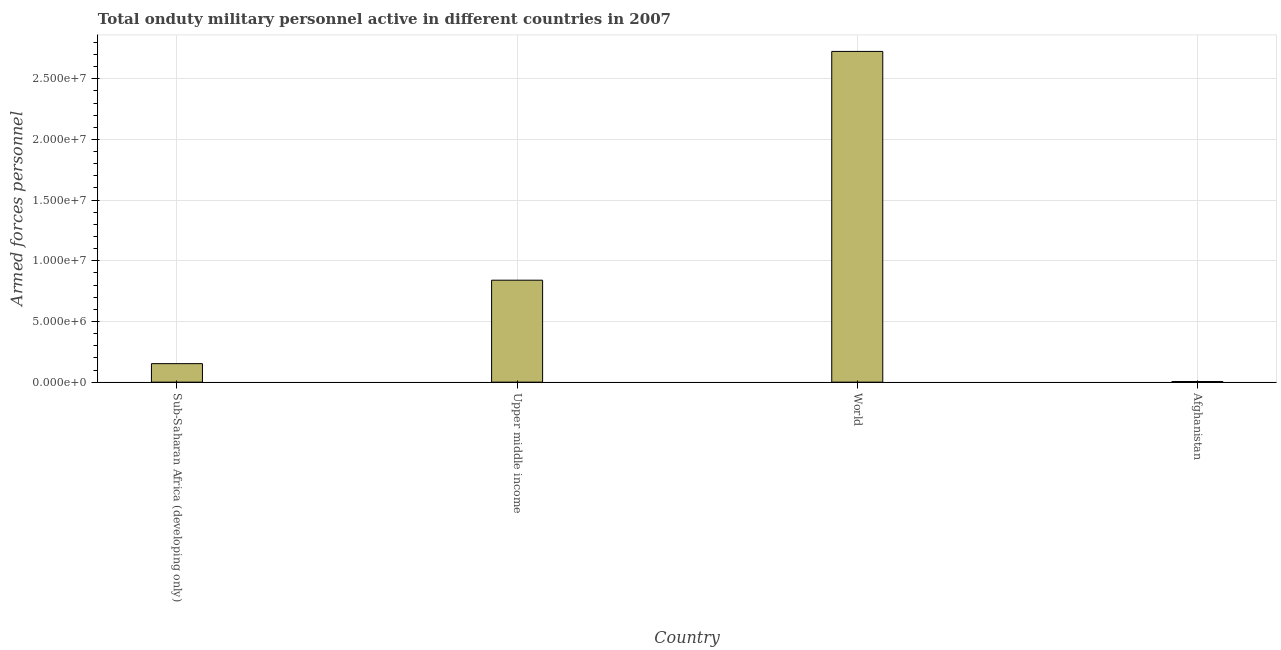Does the graph contain any zero values?
Provide a short and direct response. No. What is the title of the graph?
Your answer should be compact. Total onduty military personnel active in different countries in 2007. What is the label or title of the Y-axis?
Your response must be concise. Armed forces personnel. What is the number of armed forces personnel in Afghanistan?
Give a very brief answer. 5.10e+04. Across all countries, what is the maximum number of armed forces personnel?
Your response must be concise. 2.73e+07. Across all countries, what is the minimum number of armed forces personnel?
Your answer should be compact. 5.10e+04. In which country was the number of armed forces personnel minimum?
Ensure brevity in your answer.  Afghanistan. What is the sum of the number of armed forces personnel?
Offer a terse response. 3.72e+07. What is the difference between the number of armed forces personnel in Sub-Saharan Africa (developing only) and Upper middle income?
Keep it short and to the point. -6.88e+06. What is the average number of armed forces personnel per country?
Your response must be concise. 9.31e+06. What is the median number of armed forces personnel?
Offer a terse response. 4.96e+06. In how many countries, is the number of armed forces personnel greater than 22000000 ?
Provide a succinct answer. 1. What is the ratio of the number of armed forces personnel in Afghanistan to that in Upper middle income?
Your answer should be very brief. 0.01. Is the number of armed forces personnel in Sub-Saharan Africa (developing only) less than that in World?
Give a very brief answer. Yes. What is the difference between the highest and the second highest number of armed forces personnel?
Provide a succinct answer. 1.89e+07. What is the difference between the highest and the lowest number of armed forces personnel?
Provide a short and direct response. 2.72e+07. Are all the bars in the graph horizontal?
Offer a terse response. No. How many countries are there in the graph?
Ensure brevity in your answer.  4. What is the Armed forces personnel of Sub-Saharan Africa (developing only)?
Provide a succinct answer. 1.52e+06. What is the Armed forces personnel in Upper middle income?
Provide a short and direct response. 8.40e+06. What is the Armed forces personnel of World?
Provide a succinct answer. 2.73e+07. What is the Armed forces personnel in Afghanistan?
Provide a succinct answer. 5.10e+04. What is the difference between the Armed forces personnel in Sub-Saharan Africa (developing only) and Upper middle income?
Offer a very short reply. -6.88e+06. What is the difference between the Armed forces personnel in Sub-Saharan Africa (developing only) and World?
Your answer should be compact. -2.57e+07. What is the difference between the Armed forces personnel in Sub-Saharan Africa (developing only) and Afghanistan?
Offer a terse response. 1.47e+06. What is the difference between the Armed forces personnel in Upper middle income and World?
Ensure brevity in your answer.  -1.89e+07. What is the difference between the Armed forces personnel in Upper middle income and Afghanistan?
Make the answer very short. 8.35e+06. What is the difference between the Armed forces personnel in World and Afghanistan?
Keep it short and to the point. 2.72e+07. What is the ratio of the Armed forces personnel in Sub-Saharan Africa (developing only) to that in Upper middle income?
Offer a terse response. 0.18. What is the ratio of the Armed forces personnel in Sub-Saharan Africa (developing only) to that in World?
Keep it short and to the point. 0.06. What is the ratio of the Armed forces personnel in Sub-Saharan Africa (developing only) to that in Afghanistan?
Give a very brief answer. 29.9. What is the ratio of the Armed forces personnel in Upper middle income to that in World?
Offer a very short reply. 0.31. What is the ratio of the Armed forces personnel in Upper middle income to that in Afghanistan?
Provide a short and direct response. 164.74. What is the ratio of the Armed forces personnel in World to that in Afghanistan?
Offer a very short reply. 534.39. 